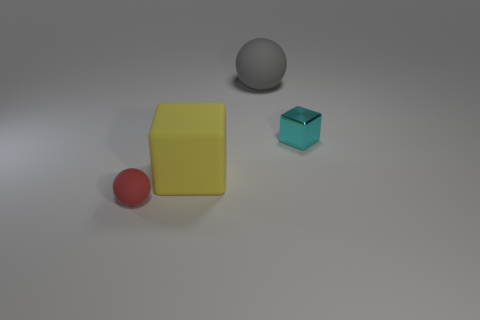Are there any tiny gray objects made of the same material as the cyan block?
Provide a short and direct response. No. Are the small object that is in front of the tiny cyan metal block and the large thing left of the gray thing made of the same material?
Ensure brevity in your answer.  Yes. Is the number of red matte objects behind the small red rubber sphere the same as the number of tiny cyan cubes that are to the right of the cyan shiny thing?
Offer a very short reply. Yes. What color is the rubber cube that is the same size as the gray sphere?
Your answer should be very brief. Yellow. Are there any large balls that have the same color as the tiny sphere?
Your answer should be very brief. No. What number of things are tiny objects behind the yellow object or tiny shiny objects?
Your answer should be very brief. 1. What number of other objects are there of the same size as the red matte sphere?
Offer a terse response. 1. What material is the object to the right of the matte sphere behind the tiny object to the left of the large gray object?
Your answer should be very brief. Metal. What number of cylinders are either gray rubber objects or tiny objects?
Offer a very short reply. 0. Are there any other things that are the same shape as the metal object?
Provide a short and direct response. Yes. 